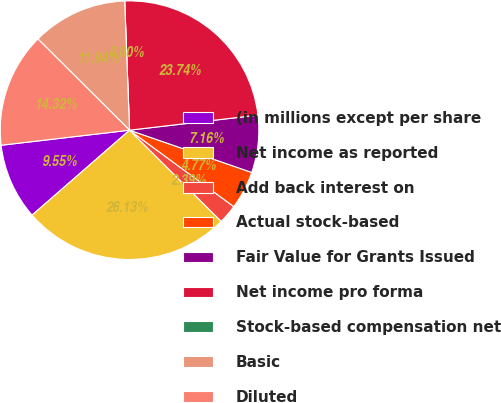<chart> <loc_0><loc_0><loc_500><loc_500><pie_chart><fcel>(in millions except per share<fcel>Net income as reported<fcel>Add back interest on<fcel>Actual stock-based<fcel>Fair Value for Grants Issued<fcel>Net income pro forma<fcel>Stock-based compensation net<fcel>Basic<fcel>Diluted<nl><fcel>9.55%<fcel>26.13%<fcel>2.39%<fcel>4.77%<fcel>7.16%<fcel>23.74%<fcel>0.0%<fcel>11.94%<fcel>14.32%<nl></chart> 